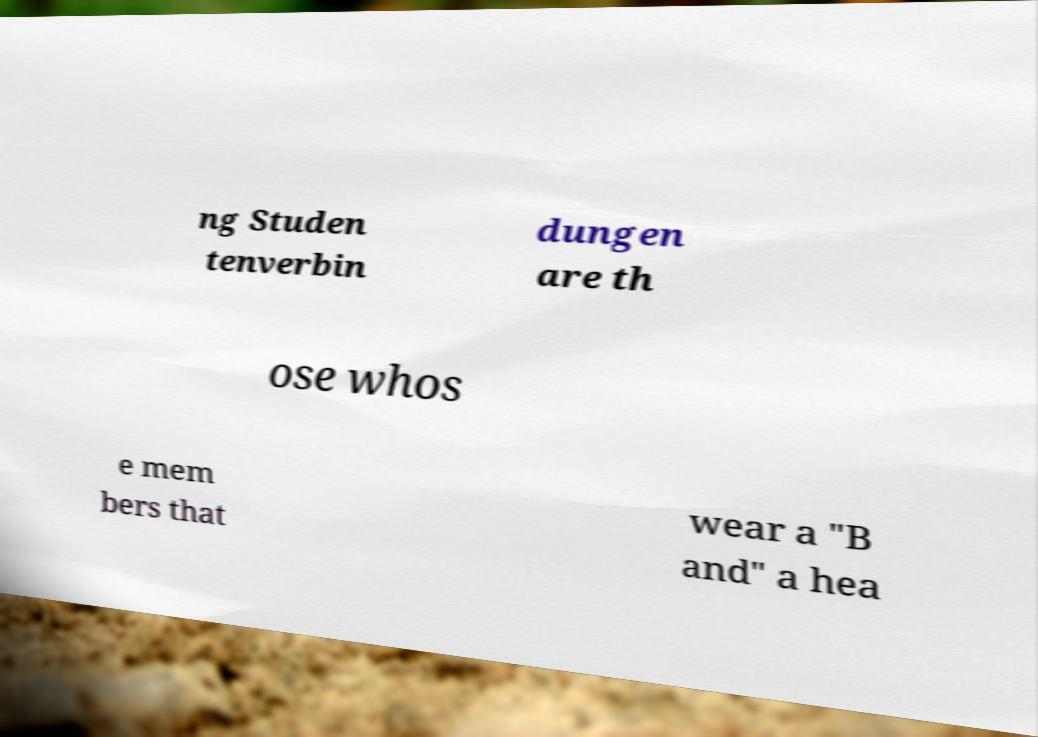What messages or text are displayed in this image? I need them in a readable, typed format. ng Studen tenverbin dungen are th ose whos e mem bers that wear a "B and" a hea 